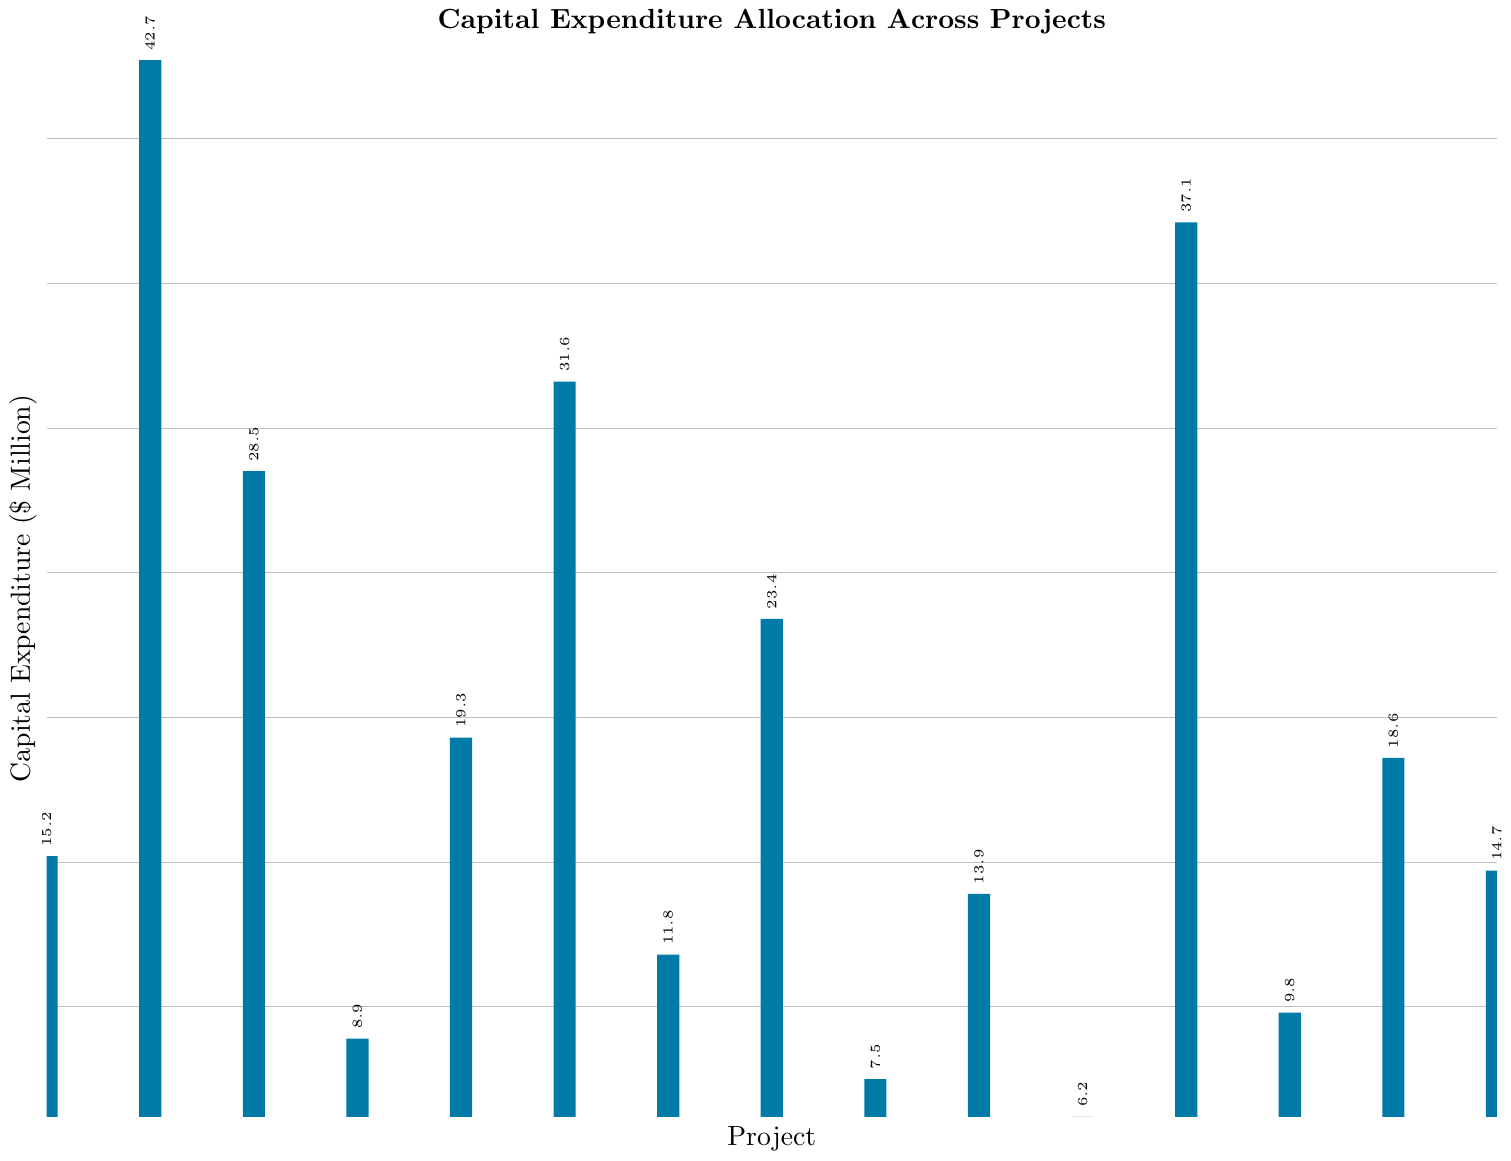Which project has the highest capital expenditure? The project with the highest bar represents the highest capital expenditure. "Manufacturing Plant Expansion" has the highest bar with a value of 42.7 million dollars.
Answer: Manufacturing Plant Expansion Which two projects have the lowest capital expenditures combined? Identify the two smallest bars and sum their values. The two smallest bars are for "Employee Training Facilities" and "Energy Efficiency Initiatives" with values 6.2 and 7.5 million dollars respectively. Their combined expenditure is 6.2 + 7.5 = 13.7 million dollars.
Answer: Employee Training Facilities and Energy Efficiency Initiatives, 13.7 million dollars How does the capital expenditure for Fleet Replacement compare to Cybersecurity Enhancement? Compare the height of the bars for "Fleet Replacement" and "Cybersecurity Enhancement". "Fleet Replacement" is 23.4 million dollars, and "Cybersecurity Enhancement" is 11.8 million dollars. Therefore, Fleet Replacement is higher.
Answer: Fleet Replacement is higher Which project has a capital expenditure closest to 20 million dollars? Identify the bar with a value closest to 20. "New Product Line Equipment" has a value of 19.3 million dollars, which is closest to 20.
Answer: New Product Line Equipment What is the total capital expenditure for Research and Development Facility, New Product Line Equipment, and Distribution Center Automation combined? Sum the capital expenditures for these three projects: Research and Development Facility (28.5), New Product Line Equipment (19.3), and Distribution Center Automation (31.6). The total is 28.5 + 19.3 + 31.6 = 79.4 million dollars.
Answer: 79.4 million dollars Which three projects have the highest capital expenditures? Identify the three tallest bars. They represent "Manufacturing Plant Expansion" (42.7), "International Market Expansion" (37.1), and "Distribution Center Automation" (31.6).
Answer: Manufacturing Plant Expansion, International Market Expansion, Distribution Center Automation Is the capital expenditure for IT Infrastructure Upgrade more than the combined expenditure of Employee Training Facilities and Data Analytics Platform? Compare "IT Infrastructure Upgrade" (15.2) against the sum of "Employee Training Facilities" (6.2) and "Data Analytics Platform" (9.8). The combined expenditure is 6.2 + 9.8 = 16, which is more than 15.2.
Answer: No What is the difference between the capital expenditures for Quality Control Systems and Customer Experience Technology? Subtract the smaller value (Customer Experience Technology, 14.7) from the larger value (Quality Control Systems, 13.9). The difference is 14.7 - 13.9 = 0.8 million dollars.
Answer: 0.8 million dollars What is the average capital expenditure per project? Sum the total capital expenditures and divide by the number of projects. The total is 15.2 + 42.7 + 28.5 + 8.9 + 19.3 + 31.6 + 11.8 + 23.4 + 7.5 + 13.9 + 6.2 + 37.1 + 9.8 + 18.6 + 14.7 = 289.2. There are 15 projects, so the average is 289.2 / 15 = 19.28 million dollars.
Answer: 19.28 million dollars If the budgets for Office Building Renovation and Data Analytics Platform were combined, would that total exceed the capital expenditure for Research and Development Facility? Sum "Office Building Renovation" (8.9) and "Data Analytics Platform" (9.8), and compare it with "Research and Development Facility" (28.5). The combined total is 8.9 + 9.8 = 18.7, which is less than 28.5.
Answer: No 